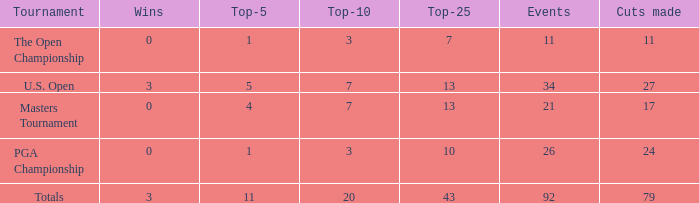Name the total number of wins with top-25 of 10 and events less than 26 0.0. 